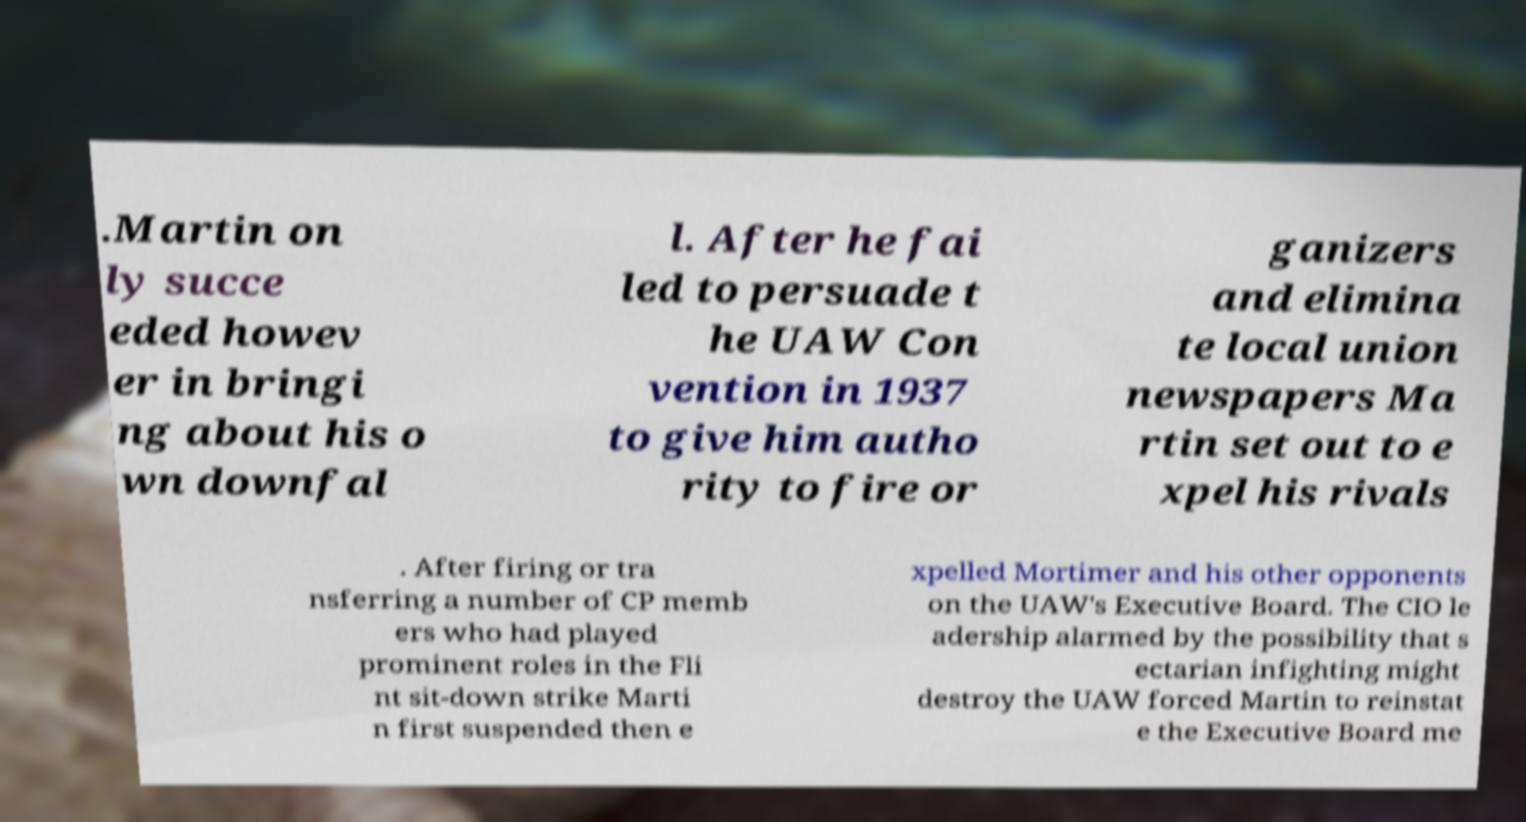Please read and relay the text visible in this image. What does it say? .Martin on ly succe eded howev er in bringi ng about his o wn downfal l. After he fai led to persuade t he UAW Con vention in 1937 to give him autho rity to fire or ganizers and elimina te local union newspapers Ma rtin set out to e xpel his rivals . After firing or tra nsferring a number of CP memb ers who had played prominent roles in the Fli nt sit-down strike Marti n first suspended then e xpelled Mortimer and his other opponents on the UAW's Executive Board. The CIO le adership alarmed by the possibility that s ectarian infighting might destroy the UAW forced Martin to reinstat e the Executive Board me 